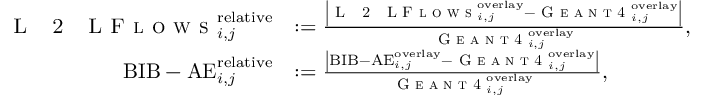Convert formula to latex. <formula><loc_0><loc_0><loc_500><loc_500>\begin{array} { r l } { L 2 L F l o w s _ { i , j } ^ { r e l a t i v e } } & { \colon = \frac { \left | L 2 L F l o w s _ { i , j } ^ { o v e r l a y } - G e a n t 4 _ { i , j } ^ { o v e r l a y } \right | } { G e a n t 4 _ { i , j } ^ { o v e r l a y } } , } \\ { B I B - A E _ { i , j } ^ { r e l a t i v e } } & { \colon = \frac { \left | B I B - A E _ { i , j } ^ { o v e r l a y } - G e a n t 4 _ { i , j } ^ { o v e r l a y } \right | } { G e a n t 4 _ { i , j } ^ { o v e r l a y } } , } \end{array}</formula> 